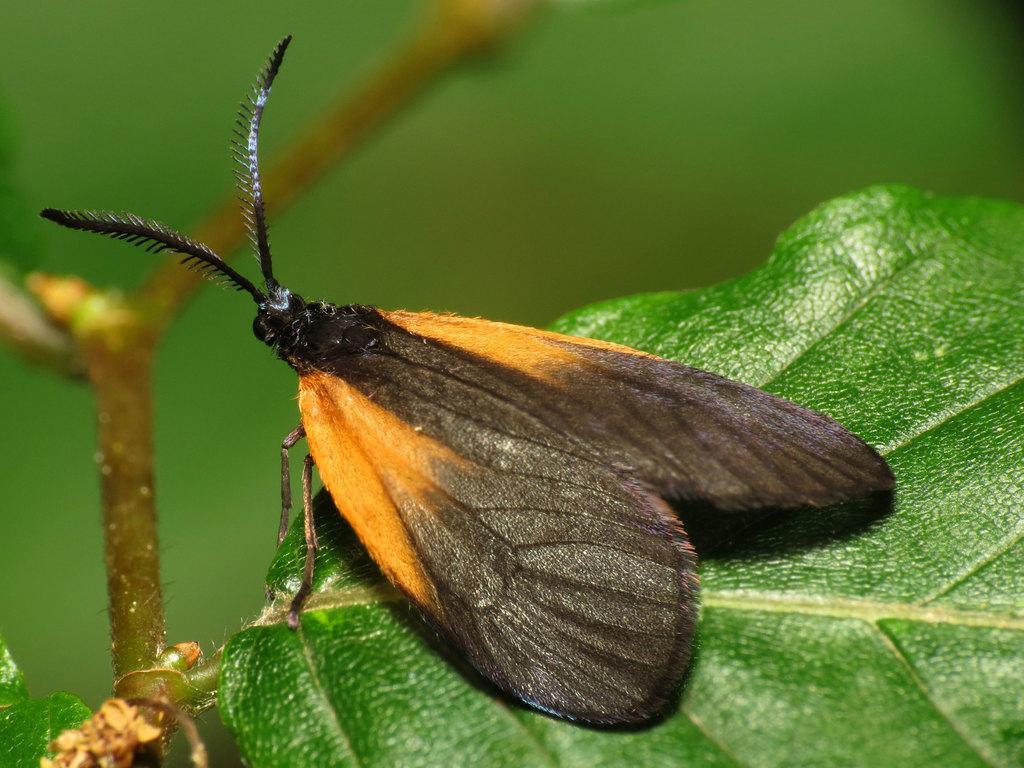Please provide a concise description of this image. In this image I can see an insect on the leaf. The insect is in orange and black color and the leaf is in green color. 